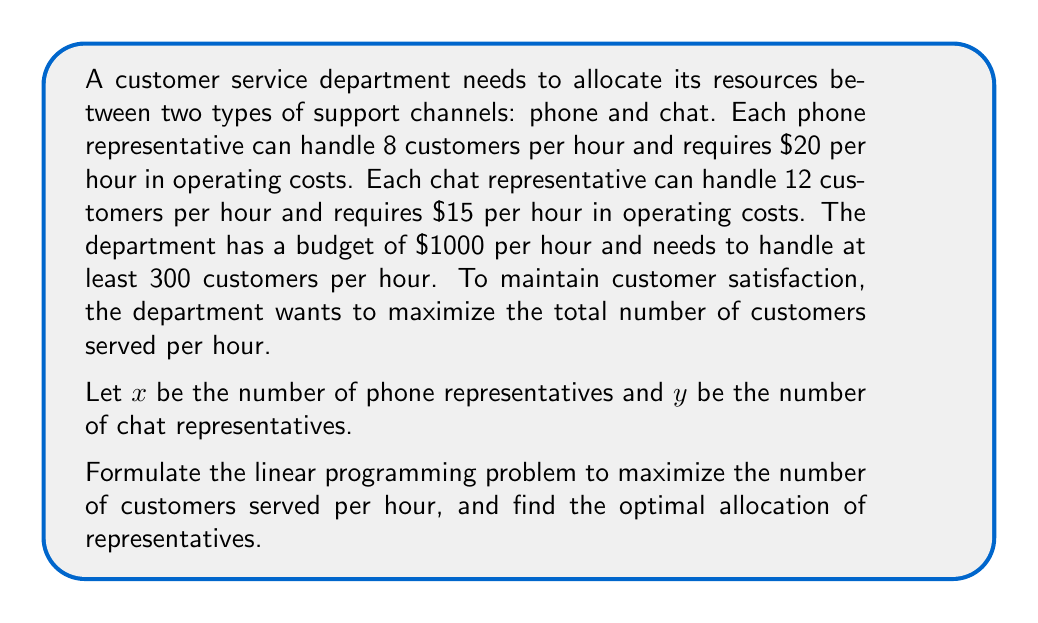Teach me how to tackle this problem. To solve this problem, we'll follow these steps:

1. Define the objective function
2. Identify the constraints
3. Set up the linear programming problem
4. Solve using the graphical method

Step 1: Define the objective function

The objective is to maximize the total number of customers served per hour.
$$ \text{Maximize } Z = 8x + 12y $$

Step 2: Identify the constraints

Budget constraint: $20x + 15y \leq 1000$
Minimum customer requirement: $8x + 12y \geq 300$
Non-negativity constraints: $x \geq 0, y \geq 0$

Step 3: Set up the linear programming problem

$$ \text{Maximize } Z = 8x + 12y $$
$$ \text{Subject to:} $$
$$ 20x + 15y \leq 1000 $$
$$ 8x + 12y \geq 300 $$
$$ x \geq 0, y \geq 0 $$

Step 4: Solve using the graphical method

a) Plot the constraints:
   - Budget: $20x + 15y = 1000$ or $y = \frac{1000}{15} - \frac{4}{3}x$
   - Minimum requirement: $8x + 12y = 300$ or $y = 25 - \frac{2}{3}x$

b) Identify the feasible region (the area that satisfies all constraints).

c) Find the corner points of the feasible region:
   - (0, 66.67) - intersection of $y = \frac{1000}{15}$ and $y$-axis
   - (37.5, 25) - intersection of minimum requirement and budget lines
   - (37.5, 0) - intersection of $x = 37.5$ and $x$-axis

d) Evaluate the objective function at each corner point:
   - (0, 66.67): $Z = 8(0) + 12(66.67) = 800$
   - (37.5, 25): $Z = 8(37.5) + 12(25) = 600$
   - (37.5, 0): $Z = 8(37.5) + 12(0) = 300$

The maximum value of Z occurs at the point (0, 66.67).
Answer: The optimal allocation is to employ 0 phone representatives and 66.67 (rounded to 67) chat representatives. This will serve a maximum of 800 customers per hour. 